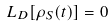Convert formula to latex. <formula><loc_0><loc_0><loc_500><loc_500>L _ { D } [ \rho _ { S } ( t ) ] = 0</formula> 